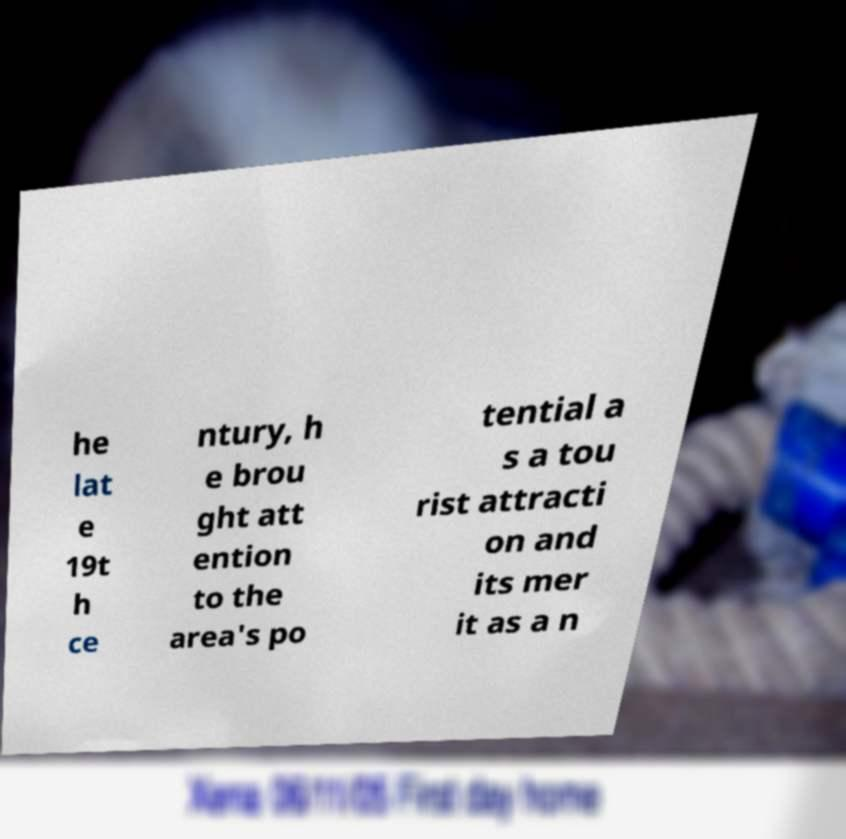What messages or text are displayed in this image? I need them in a readable, typed format. he lat e 19t h ce ntury, h e brou ght att ention to the area's po tential a s a tou rist attracti on and its mer it as a n 